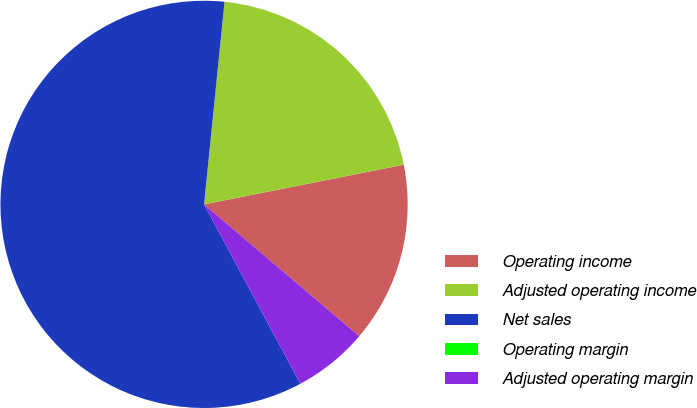<chart> <loc_0><loc_0><loc_500><loc_500><pie_chart><fcel>Operating income<fcel>Adjusted operating income<fcel>Net sales<fcel>Operating margin<fcel>Adjusted operating margin<nl><fcel>14.33%<fcel>20.28%<fcel>59.44%<fcel>0.0%<fcel>5.95%<nl></chart> 